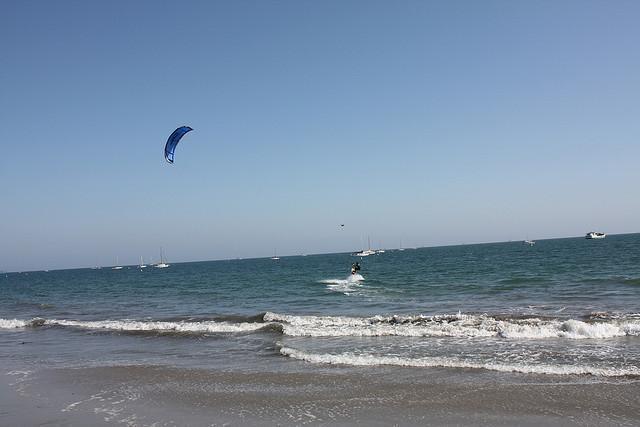The shape of the paragliding inflatable wing is?
Indicate the correct response and explain using: 'Answer: answer
Rationale: rationale.'
Options: Round, circular, triangle, elliptical. Answer: elliptical.
Rationale: The shape of the wing is an ellipsis. 